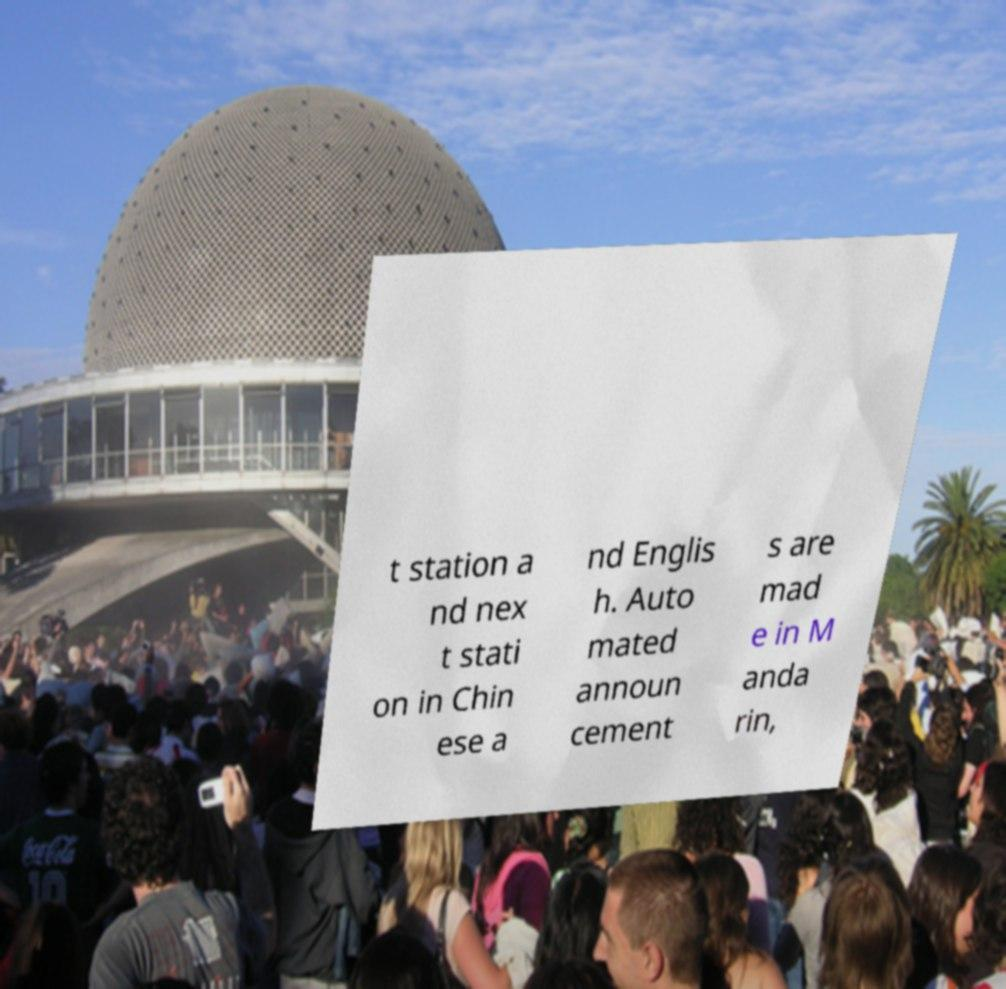For documentation purposes, I need the text within this image transcribed. Could you provide that? t station a nd nex t stati on in Chin ese a nd Englis h. Auto mated announ cement s are mad e in M anda rin, 